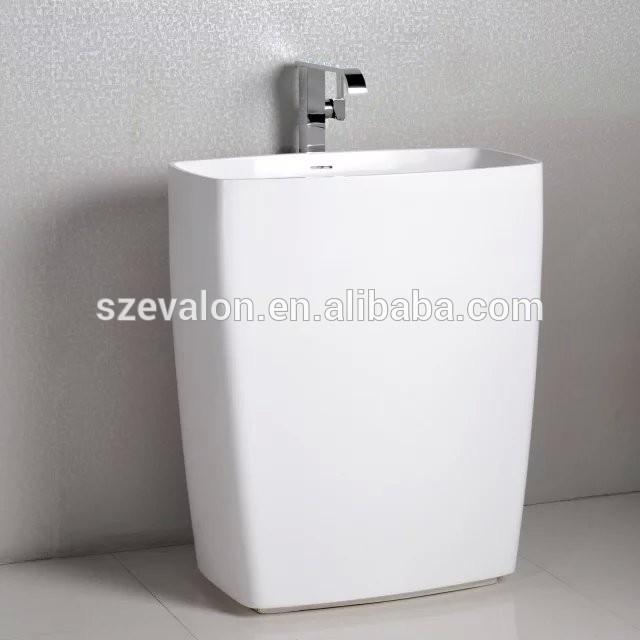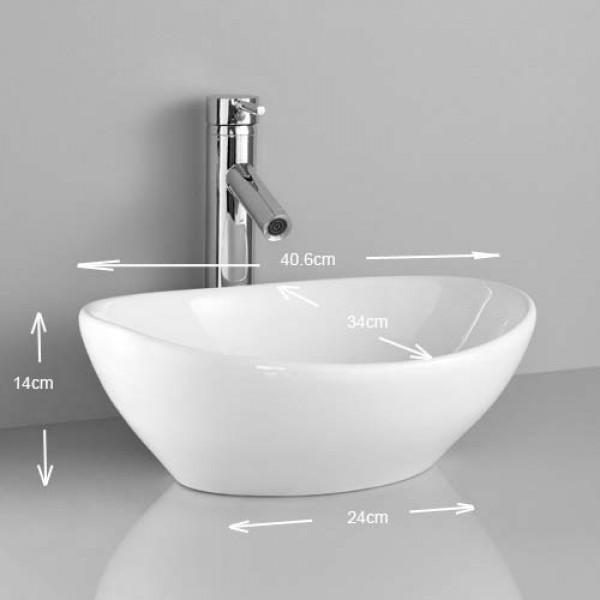The first image is the image on the left, the second image is the image on the right. Given the left and right images, does the statement "The right image shows an oblong bowl-shaped sink." hold true? Answer yes or no. Yes. 